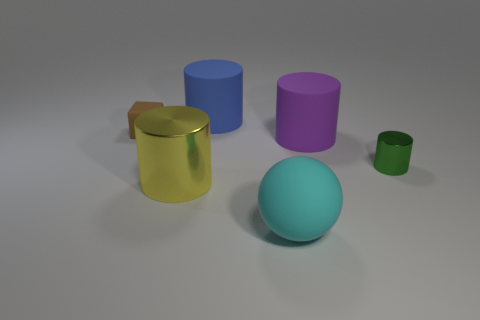Is there another metallic thing that has the same shape as the large yellow shiny thing?
Ensure brevity in your answer.  Yes. What number of things are big rubber things that are to the left of the big cyan rubber thing or big cyan cylinders?
Your answer should be very brief. 1. There is a cylinder that is behind the purple rubber cylinder; does it have the same color as the big matte thing in front of the purple matte thing?
Your answer should be very brief. No. The purple cylinder is what size?
Offer a very short reply. Large. How many tiny things are green cylinders or purple things?
Your response must be concise. 1. What is the color of the shiny cylinder that is the same size as the matte sphere?
Your response must be concise. Yellow. What number of other objects are there of the same shape as the big purple rubber thing?
Provide a short and direct response. 3. Is there a green cube made of the same material as the yellow thing?
Your answer should be very brief. No. Do the big thing that is in front of the large shiny cylinder and the tiny thing that is in front of the block have the same material?
Provide a short and direct response. No. What number of blue matte blocks are there?
Provide a succinct answer. 0. 